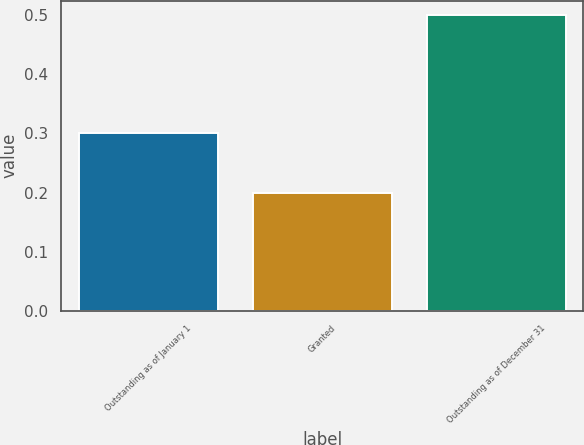Convert chart. <chart><loc_0><loc_0><loc_500><loc_500><bar_chart><fcel>Outstanding as of January 1<fcel>Granted<fcel>Outstanding as of December 31<nl><fcel>0.3<fcel>0.2<fcel>0.5<nl></chart> 